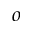<formula> <loc_0><loc_0><loc_500><loc_500>o</formula> 